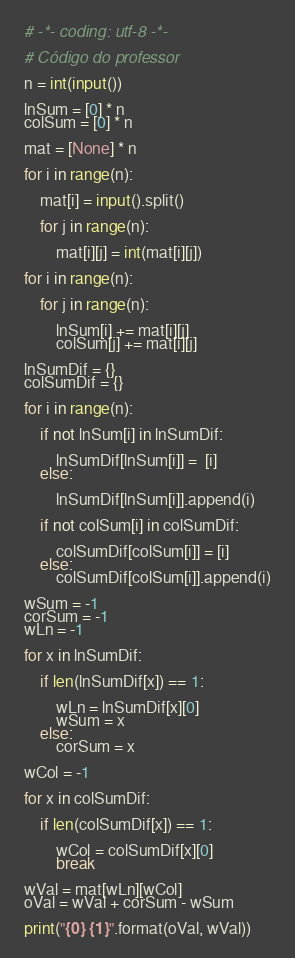Convert code to text. <code><loc_0><loc_0><loc_500><loc_500><_Python_># -*- coding: utf-8 -*-

# Código do professor

n = int(input())

lnSum = [0] * n
colSum = [0] * n

mat = [None] * n

for i in range(n):

    mat[i] = input().split()

    for j in range(n):

        mat[i][j] = int(mat[i][j])

for i in range(n):

    for j in range(n):

        lnSum[i] += mat[i][j]
        colSum[j] += mat[i][j]

lnSumDif = {}
colSumDif = {}

for i in range(n):

    if not lnSum[i] in lnSumDif:
        
        lnSumDif[lnSum[i]] =  [i]
    else:

        lnSumDif[lnSum[i]].append(i)
        
    if not colSum[i] in colSumDif:

        colSumDif[colSum[i]] = [i]
    else:
        colSumDif[colSum[i]].append(i)

wSum = -1
corSum = -1
wLn = -1

for x in lnSumDif:
    
    if len(lnSumDif[x]) == 1:

        wLn = lnSumDif[x][0]
        wSum = x
    else:
        corSum = x

wCol = -1

for x in colSumDif:

    if len(colSumDif[x]) == 1:

        wCol = colSumDif[x][0]
        break
        
wVal = mat[wLn][wCol]
oVal = wVal + corSum - wSum

print("{0} {1}".format(oVal, wVal))</code> 